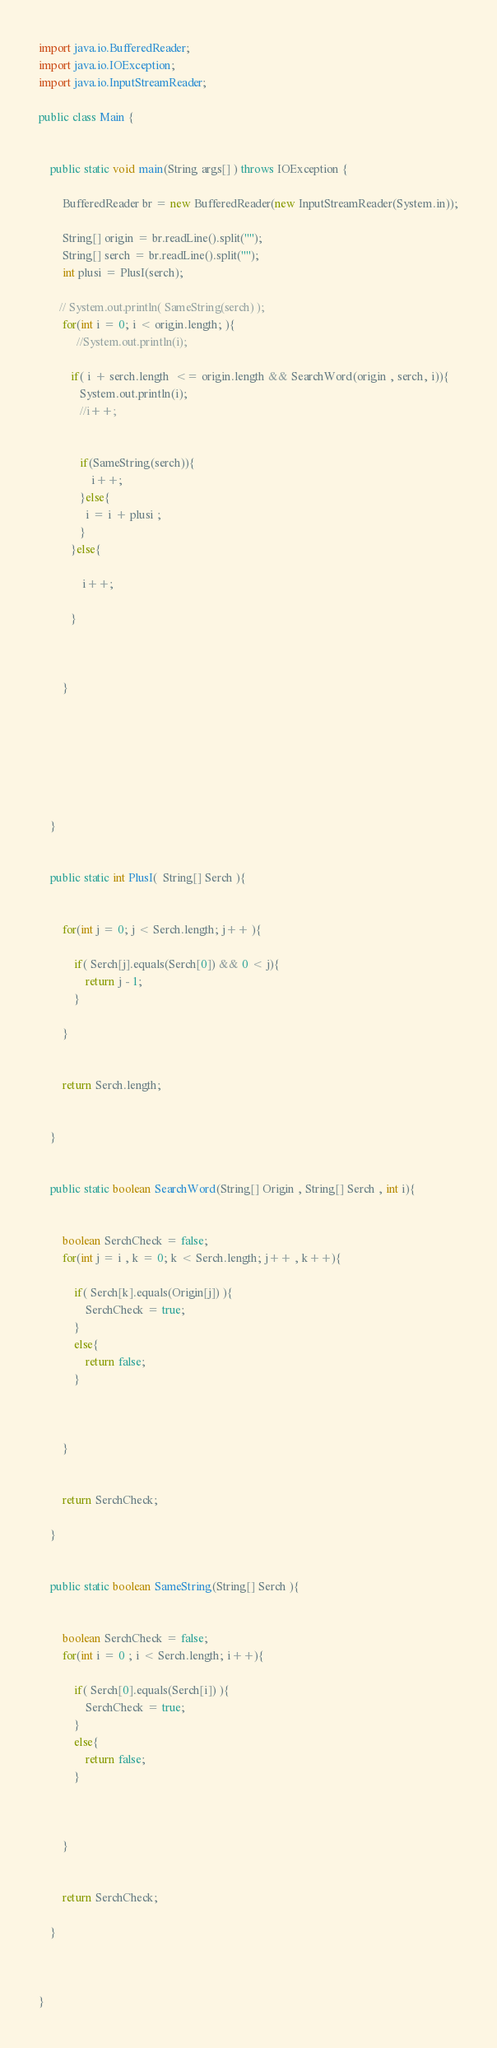<code> <loc_0><loc_0><loc_500><loc_500><_Java_>import java.io.BufferedReader;
import java.io.IOException;
import java.io.InputStreamReader;

public class Main {


    public static void main(String args[] ) throws IOException {

        BufferedReader br = new BufferedReader(new InputStreamReader(System.in));

        String[] origin = br.readLine().split("");
        String[] serch = br.readLine().split("");
        int plusi = PlusI(serch);

       // System.out.println( SameString(serch) );
        for(int i = 0; i < origin.length; ){
        	 //System.out.println(i);

           if( i + serch.length  <= origin.length && SearchWord(origin , serch, i)){
              System.out.println(i);
              //i++;


              if(SameString(serch)){
            	  i++;
              }else{
                i = i + plusi ;
              }
           }else{

        	   i++;

           }



        }







    }


    public static int PlusI(  String[] Serch ){


    	for(int j = 0; j < Serch.length; j++ ){

    	    if( Serch[j].equals(Serch[0]) && 0 < j){
    	    	return j - 1;
    	    }

    	}


        return Serch.length;


    }


    public static boolean SearchWord(String[] Origin , String[] Serch , int i){


    	boolean SerchCheck = false;
    	for(int j = i , k = 0; k < Serch.length; j++ , k++){

    	    if( Serch[k].equals(Origin[j]) ){
    	    	SerchCheck = true;
    	    }
    	    else{
    	    	return false;
    	    }



    	}


    	return SerchCheck;

    }


    public static boolean SameString(String[] Serch ){


    	boolean SerchCheck = false;
    	for(int i = 0 ; i < Serch.length; i++){

    	    if( Serch[0].equals(Serch[i]) ){
    	    	SerchCheck = true;
    	    }
    	    else{
    	    	return false;
    	    }



    	}


    	return SerchCheck;

    }



}</code> 